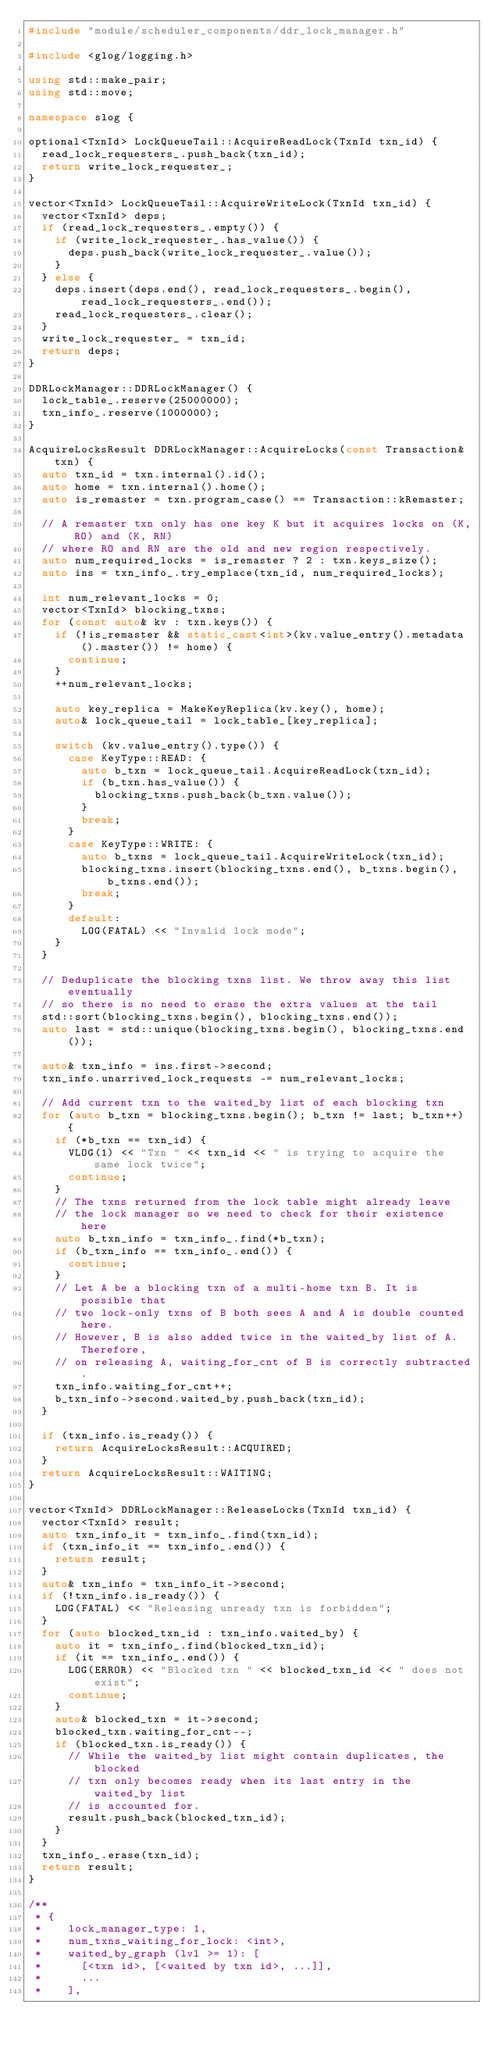<code> <loc_0><loc_0><loc_500><loc_500><_C++_>#include "module/scheduler_components/ddr_lock_manager.h"

#include <glog/logging.h>

using std::make_pair;
using std::move;

namespace slog {

optional<TxnId> LockQueueTail::AcquireReadLock(TxnId txn_id) {
  read_lock_requesters_.push_back(txn_id);
  return write_lock_requester_;
}

vector<TxnId> LockQueueTail::AcquireWriteLock(TxnId txn_id) {
  vector<TxnId> deps;
  if (read_lock_requesters_.empty()) {
    if (write_lock_requester_.has_value()) {
      deps.push_back(write_lock_requester_.value());
    }
  } else {
    deps.insert(deps.end(), read_lock_requesters_.begin(), read_lock_requesters_.end());
    read_lock_requesters_.clear();
  }
  write_lock_requester_ = txn_id;
  return deps;
}

DDRLockManager::DDRLockManager() {
  lock_table_.reserve(25000000);
  txn_info_.reserve(1000000);
}

AcquireLocksResult DDRLockManager::AcquireLocks(const Transaction& txn) {
  auto txn_id = txn.internal().id();
  auto home = txn.internal().home();
  auto is_remaster = txn.program_case() == Transaction::kRemaster;

  // A remaster txn only has one key K but it acquires locks on (K, RO) and (K, RN)
  // where RO and RN are the old and new region respectively.
  auto num_required_locks = is_remaster ? 2 : txn.keys_size();
  auto ins = txn_info_.try_emplace(txn_id, num_required_locks);

  int num_relevant_locks = 0;
  vector<TxnId> blocking_txns;
  for (const auto& kv : txn.keys()) {
    if (!is_remaster && static_cast<int>(kv.value_entry().metadata().master()) != home) {
      continue;
    }
    ++num_relevant_locks;

    auto key_replica = MakeKeyReplica(kv.key(), home);
    auto& lock_queue_tail = lock_table_[key_replica];

    switch (kv.value_entry().type()) {
      case KeyType::READ: {
        auto b_txn = lock_queue_tail.AcquireReadLock(txn_id);
        if (b_txn.has_value()) {
          blocking_txns.push_back(b_txn.value());
        }
        break;
      }
      case KeyType::WRITE: {
        auto b_txns = lock_queue_tail.AcquireWriteLock(txn_id);
        blocking_txns.insert(blocking_txns.end(), b_txns.begin(), b_txns.end());
        break;
      }
      default:
        LOG(FATAL) << "Invalid lock mode";
    }
  }

  // Deduplicate the blocking txns list. We throw away this list eventually
  // so there is no need to erase the extra values at the tail
  std::sort(blocking_txns.begin(), blocking_txns.end());
  auto last = std::unique(blocking_txns.begin(), blocking_txns.end());

  auto& txn_info = ins.first->second;
  txn_info.unarrived_lock_requests -= num_relevant_locks;

  // Add current txn to the waited_by list of each blocking txn
  for (auto b_txn = blocking_txns.begin(); b_txn != last; b_txn++) {
    if (*b_txn == txn_id) {
      VLOG(1) << "Txn " << txn_id << " is trying to acquire the same lock twice";
      continue;
    }
    // The txns returned from the lock table might already leave
    // the lock manager so we need to check for their existence here
    auto b_txn_info = txn_info_.find(*b_txn);
    if (b_txn_info == txn_info_.end()) {
      continue;
    }
    // Let A be a blocking txn of a multi-home txn B. It is possible that
    // two lock-only txns of B both sees A and A is double counted here.
    // However, B is also added twice in the waited_by list of A. Therefore,
    // on releasing A, waiting_for_cnt of B is correctly subtracted.
    txn_info.waiting_for_cnt++;
    b_txn_info->second.waited_by.push_back(txn_id);
  }

  if (txn_info.is_ready()) {
    return AcquireLocksResult::ACQUIRED;
  }
  return AcquireLocksResult::WAITING;
}

vector<TxnId> DDRLockManager::ReleaseLocks(TxnId txn_id) {
  vector<TxnId> result;
  auto txn_info_it = txn_info_.find(txn_id);
  if (txn_info_it == txn_info_.end()) {
    return result;
  }
  auto& txn_info = txn_info_it->second;
  if (!txn_info.is_ready()) {
    LOG(FATAL) << "Releasing unready txn is forbidden";
  }
  for (auto blocked_txn_id : txn_info.waited_by) {
    auto it = txn_info_.find(blocked_txn_id);
    if (it == txn_info_.end()) {
      LOG(ERROR) << "Blocked txn " << blocked_txn_id << " does not exist";
      continue;
    }
    auto& blocked_txn = it->second;
    blocked_txn.waiting_for_cnt--;
    if (blocked_txn.is_ready()) {
      // While the waited_by list might contain duplicates, the blocked
      // txn only becomes ready when its last entry in the waited_by list
      // is accounted for.
      result.push_back(blocked_txn_id);
    }
  }
  txn_info_.erase(txn_id);
  return result;
}

/**
 * {
 *    lock_manager_type: 1,
 *    num_txns_waiting_for_lock: <int>,
 *    waited_by_graph (lvl >= 1): [
 *      [<txn id>, [<waited by txn id>, ...]],
 *      ...
 *    ],</code> 